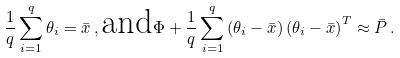<formula> <loc_0><loc_0><loc_500><loc_500>\frac { 1 } { q } \sum _ { i = 1 } ^ { q } \theta _ { i } = \bar { x } \, , \text {and} \Phi + \frac { 1 } { q } \sum _ { i = 1 } ^ { q } \left ( \theta _ { i } - \bar { x } \right ) \left ( \theta _ { i } - \bar { x } \right ) ^ { T } \approx \bar { P } \, .</formula> 